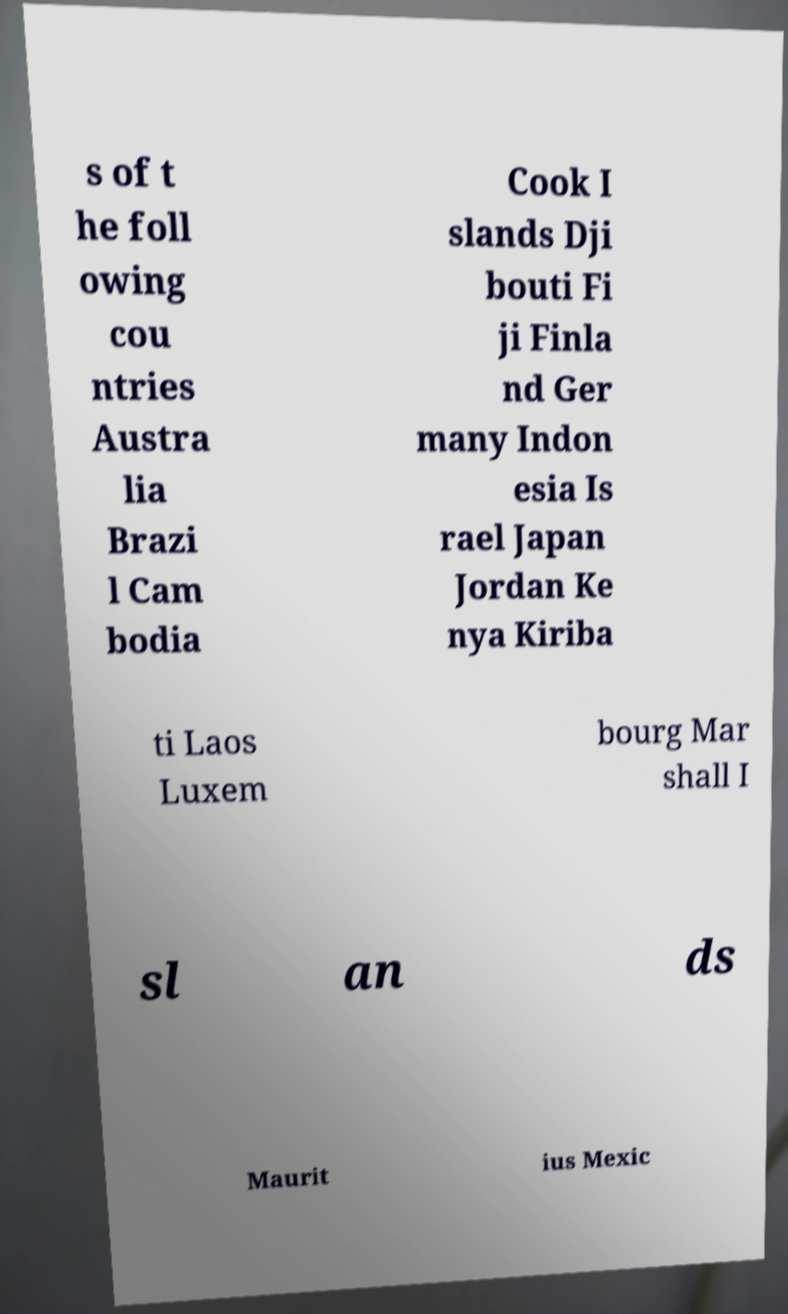Could you extract and type out the text from this image? s of t he foll owing cou ntries Austra lia Brazi l Cam bodia Cook I slands Dji bouti Fi ji Finla nd Ger many Indon esia Is rael Japan Jordan Ke nya Kiriba ti Laos Luxem bourg Mar shall I sl an ds Maurit ius Mexic 